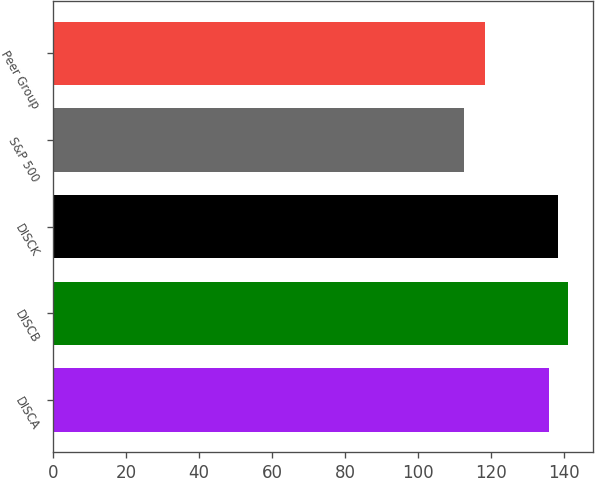Convert chart to OTSL. <chart><loc_0><loc_0><loc_500><loc_500><bar_chart><fcel>DISCA<fcel>DISCB<fcel>DISCK<fcel>S&P 500<fcel>Peer Group<nl><fcel>135.96<fcel>141.16<fcel>138.56<fcel>112.78<fcel>118.4<nl></chart> 